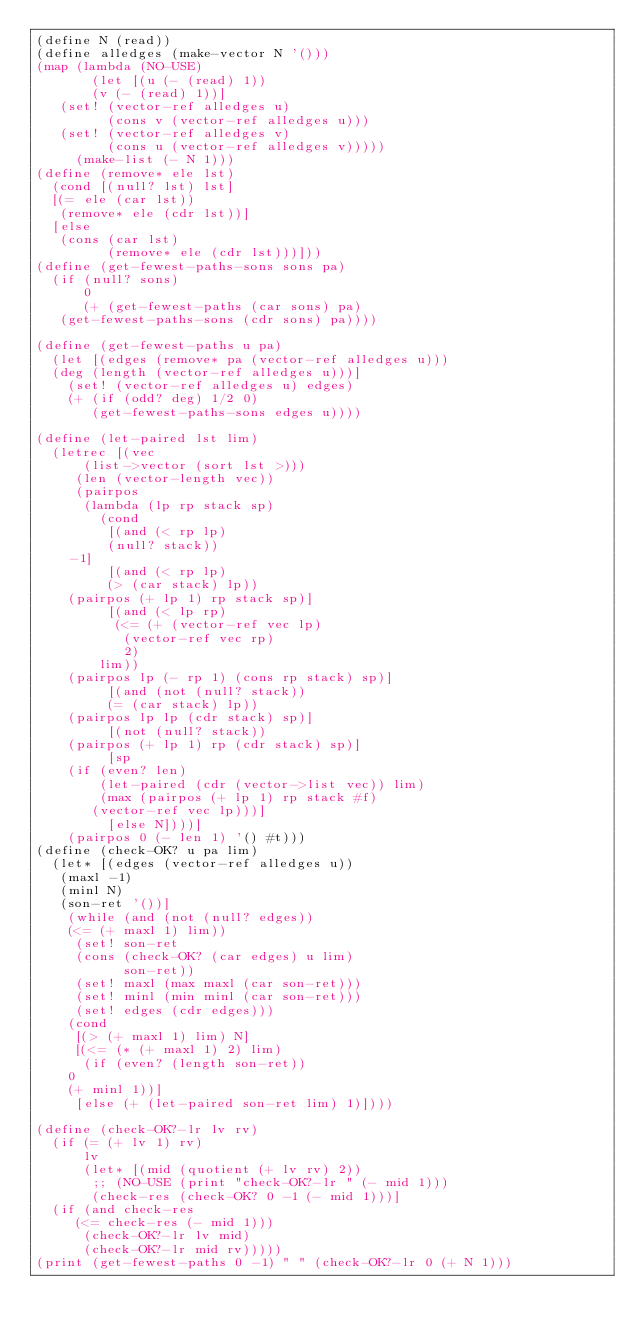Convert code to text. <code><loc_0><loc_0><loc_500><loc_500><_Scheme_>(define N (read))
(define alledges (make-vector N '()))
(map (lambda (NO-USE)
       (let [(u (- (read) 1))
	     (v (- (read) 1))]
	 (set! (vector-ref alledges u)
	       (cons v (vector-ref alledges u)))
	 (set! (vector-ref alledges v)
	       (cons u (vector-ref alledges v)))))
     (make-list (- N 1)))
(define (remove* ele lst)
  (cond [(null? lst) lst]
	[(= ele (car lst))
	 (remove* ele (cdr lst))]
	[else
	 (cons (car lst)
	       (remove* ele (cdr lst)))]))
(define (get-fewest-paths-sons sons pa)
  (if (null? sons)
      0
      (+ (get-fewest-paths (car sons) pa)
	 (get-fewest-paths-sons (cdr sons) pa))))

(define (get-fewest-paths u pa)
  (let [(edges (remove* pa (vector-ref alledges u)))
	(deg (length (vector-ref alledges u)))]
    (set! (vector-ref alledges u) edges)
    (+ (if (odd? deg) 1/2 0)
       (get-fewest-paths-sons edges u))))

(define (let-paired lst lim)
  (letrec [(vec
	    (list->vector (sort lst >)))
	   (len (vector-length vec))
	   (pairpos
	    (lambda (lp rp stack sp)
	      (cond
	       [(and (< rp lp)
		     (null? stack))
		-1]
	       [(and (< rp lp)
		     (> (car stack) lp))
		(pairpos (+ lp 1) rp stack sp)]
	       [(and (< lp rp)
			    (<= (+ (vector-ref vec lp)
				   (vector-ref vec rp)
				   2)
				lim))
		(pairpos lp (- rp 1) (cons rp stack) sp)]
	       [(and (not (null? stack))
		     (= (car stack) lp))
		(pairpos lp lp (cdr stack) sp)]
	       [(not (null? stack))
		(pairpos (+ lp 1) rp (cdr stack) sp)]
	       [sp
		(if (even? len)
		    (let-paired (cdr (vector->list vec)) lim)
		    (max (pairpos (+ lp 1) rp stack #f)
			 (vector-ref vec lp)))]
	       [else N])))]
    (pairpos 0 (- len 1) '() #t)))
(define (check-OK? u pa lim)
  (let* [(edges (vector-ref alledges u))
	 (maxl -1)
	 (minl N)
	 (son-ret '())]
    (while (and (not (null? edges))
		(<= (+ maxl 1) lim))
	   (set! son-ret
		 (cons (check-OK? (car edges) u lim)
		       son-ret))
	   (set! maxl (max maxl (car son-ret)))
	   (set! minl (min minl (car son-ret)))
	   (set! edges (cdr edges)))
    (cond
     [(> (+ maxl 1) lim) N]
     [(<= (* (+ maxl 1) 2) lim)
      (if (even? (length son-ret))
	  0
	  (+ minl 1))]
     [else (+ (let-paired son-ret lim) 1)])))

(define (check-OK?-lr lv rv)
  (if (= (+ lv 1) rv)
      lv
      (let* [(mid (quotient (+ lv rv) 2))
	     ;; (NO-USE (print "check-OK?-lr " (- mid 1)))
	     (check-res (check-OK? 0 -1 (- mid 1)))]
	(if (and check-res
		 (<= check-res (- mid 1)))
	    (check-OK?-lr lv mid)
	    (check-OK?-lr mid rv)))))
(print (get-fewest-paths 0 -1) " " (check-OK?-lr 0 (+ N 1)))
</code> 